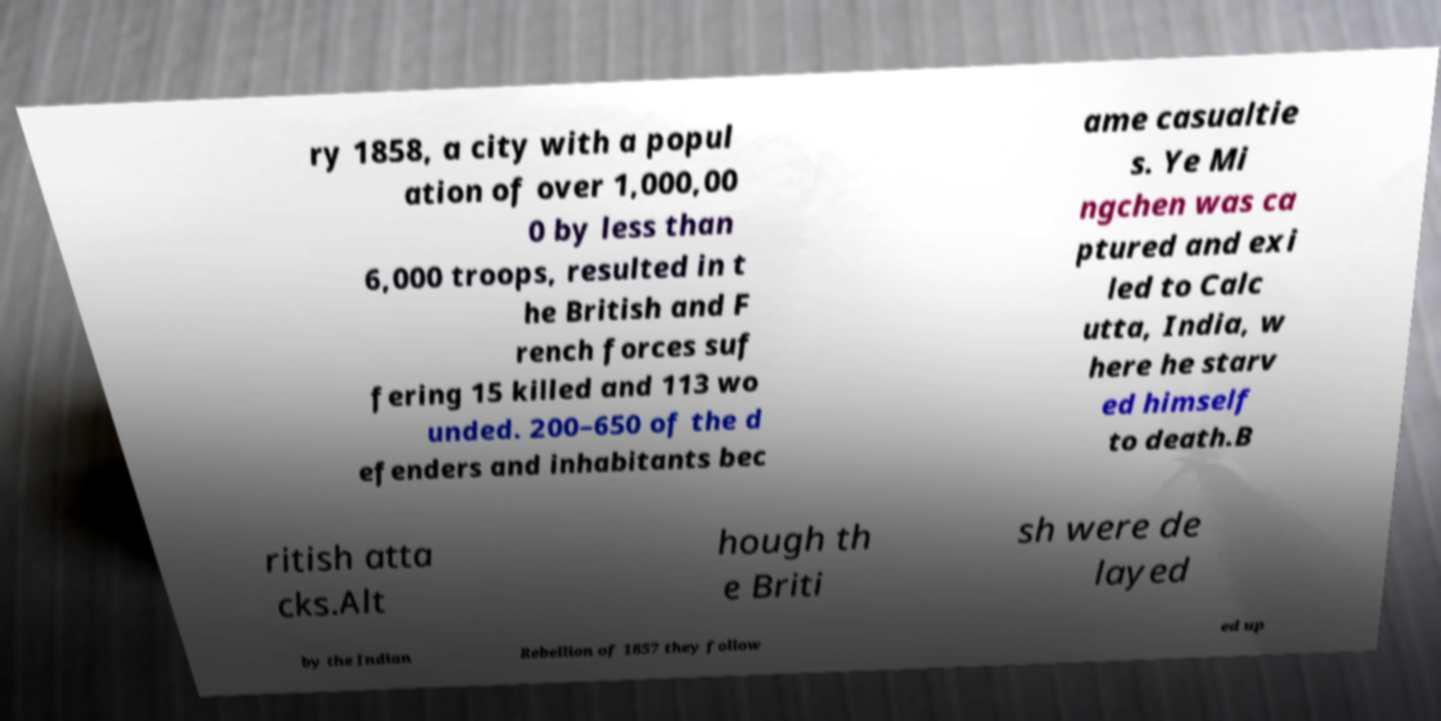Please identify and transcribe the text found in this image. ry 1858, a city with a popul ation of over 1,000,00 0 by less than 6,000 troops, resulted in t he British and F rench forces suf fering 15 killed and 113 wo unded. 200–650 of the d efenders and inhabitants bec ame casualtie s. Ye Mi ngchen was ca ptured and exi led to Calc utta, India, w here he starv ed himself to death.B ritish atta cks.Alt hough th e Briti sh were de layed by the Indian Rebellion of 1857 they follow ed up 